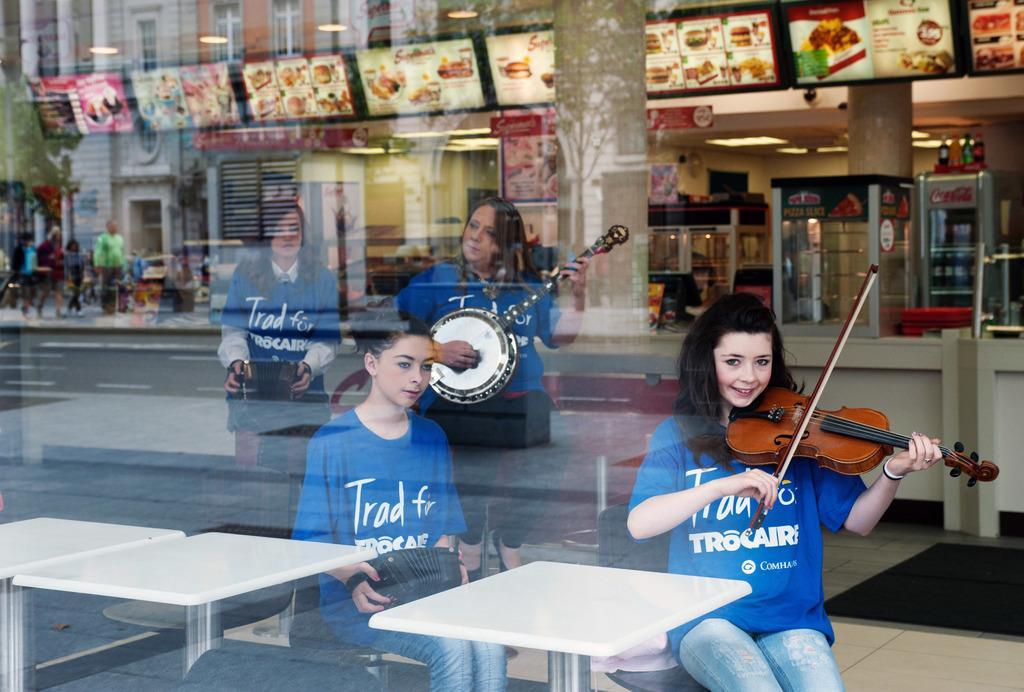Please provide a concise description of this image. In the image we can see there are woman who are sitting and playing a musical instrument and at the back there are buildings and shops and people are standing on the footpath. 